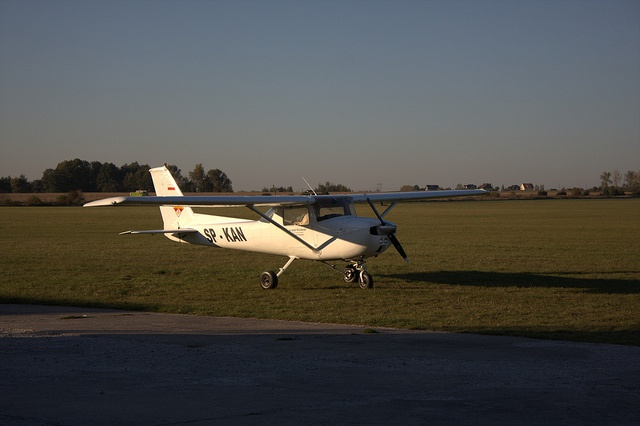Describe the objects in this image and their specific colors. I can see a airplane in gray, black, and tan tones in this image. 